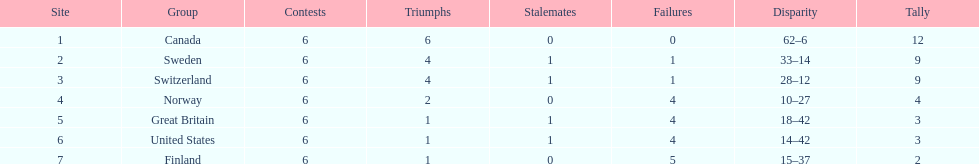Which country's team came in last place during the 1951 world ice hockey championships? Finland. 